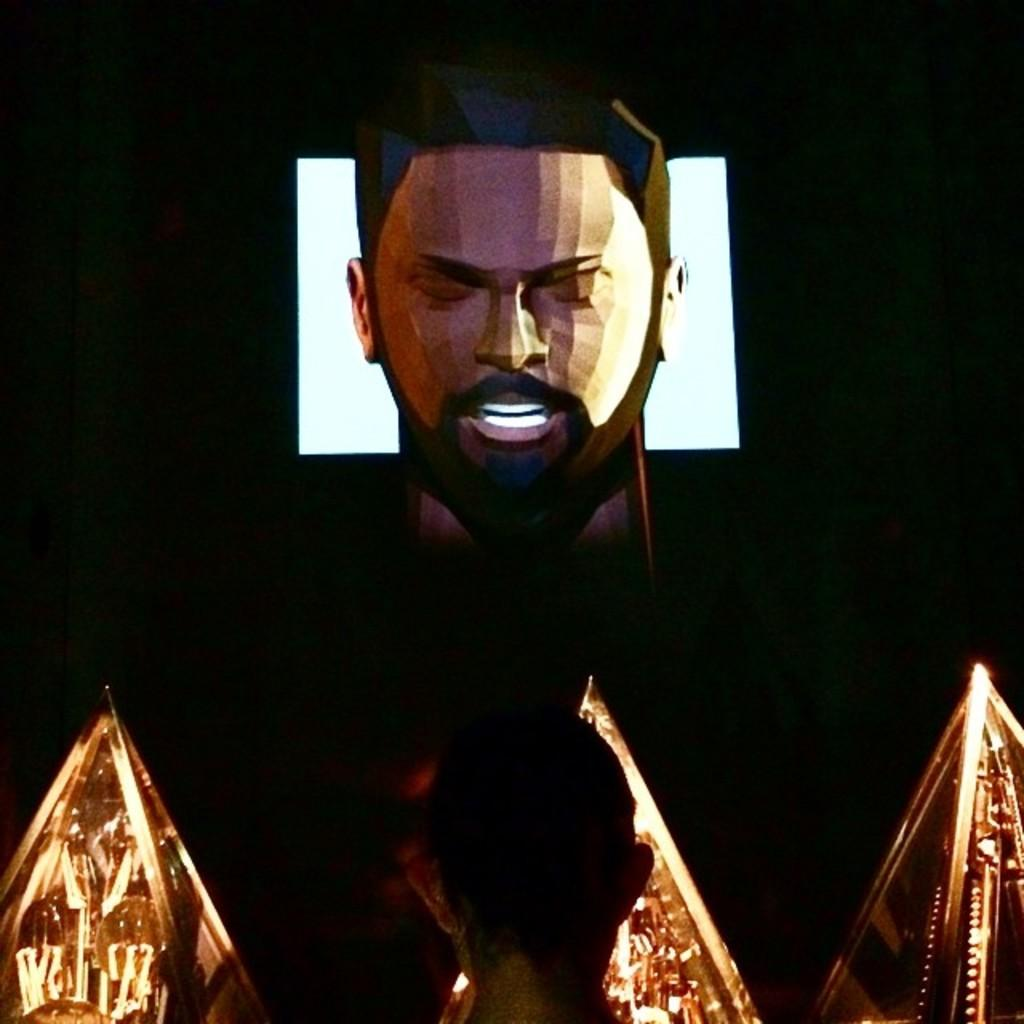What type of objects have lights in the image? There are objects with lights in the image, but the specific type of objects is not mentioned. Can you describe the person at the bottom of the image? There is a person at the bottom of the image, but their appearance or actions are not described. What is depicted in the painted image in the middle of the image? The painted image in the middle of the image is of a person, but no further details about the person or the painting are provided. What color is the background of the image? The background of the image is black. How is the reward distributed among the people in the image? There is no mention of a reward or distribution in the image. What type of hat is the person wearing in the image? There is no mention of a hat or any person wearing a hat in the image. 